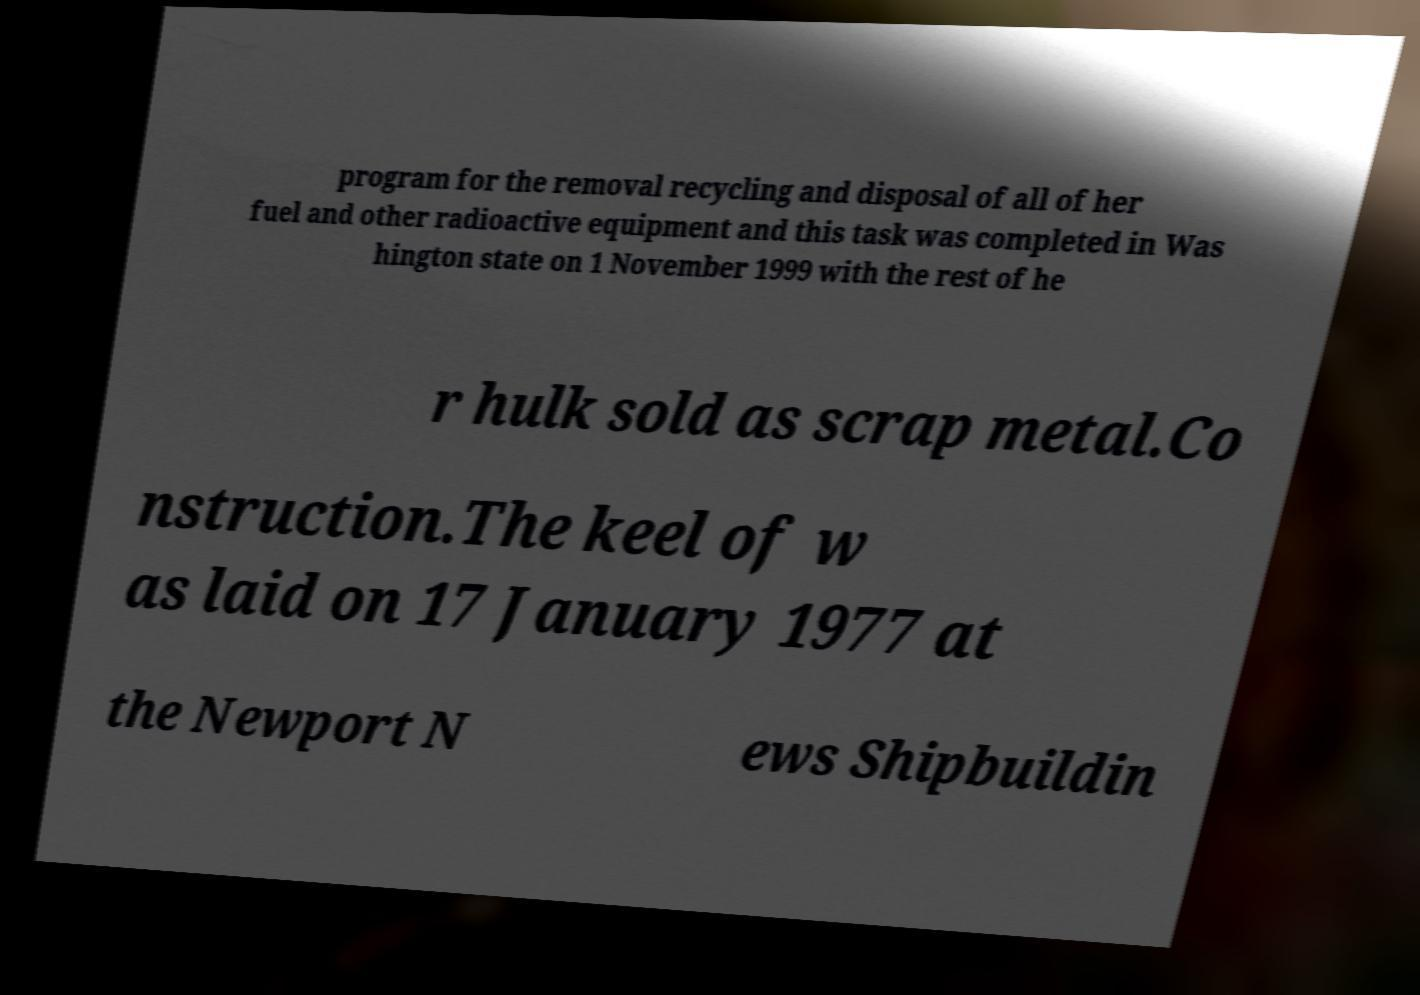Please identify and transcribe the text found in this image. program for the removal recycling and disposal of all of her fuel and other radioactive equipment and this task was completed in Was hington state on 1 November 1999 with the rest of he r hulk sold as scrap metal.Co nstruction.The keel of w as laid on 17 January 1977 at the Newport N ews Shipbuildin 